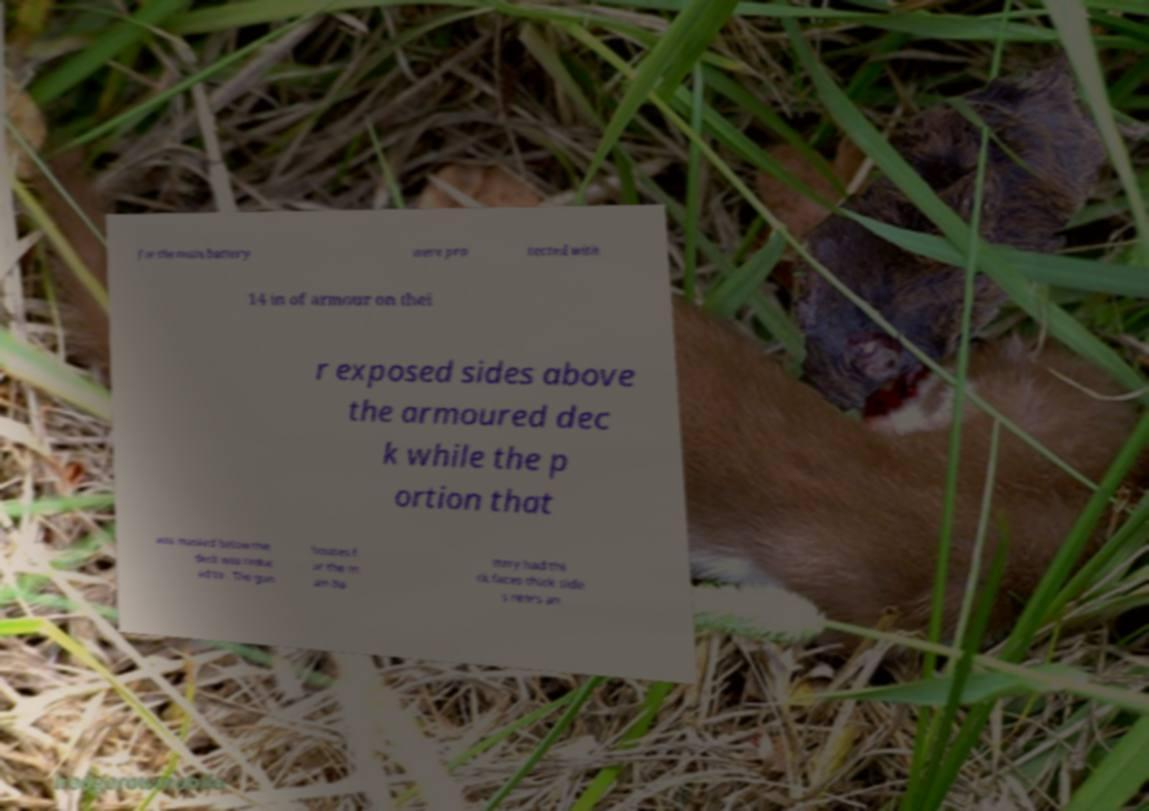Can you read and provide the text displayed in the image?This photo seems to have some interesting text. Can you extract and type it out for me? for the main battery were pro tected with 14 in of armour on thei r exposed sides above the armoured dec k while the p ortion that was masked below the deck was reduc ed to . The gun houses f or the m ain ba ttery had thi ck faces thick side s rears an 